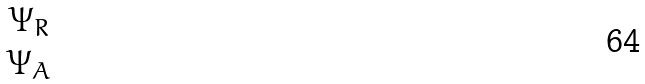<formula> <loc_0><loc_0><loc_500><loc_500>\begin{matrix} \Psi _ { R } \\ \Psi _ { A } \end{matrix}</formula> 